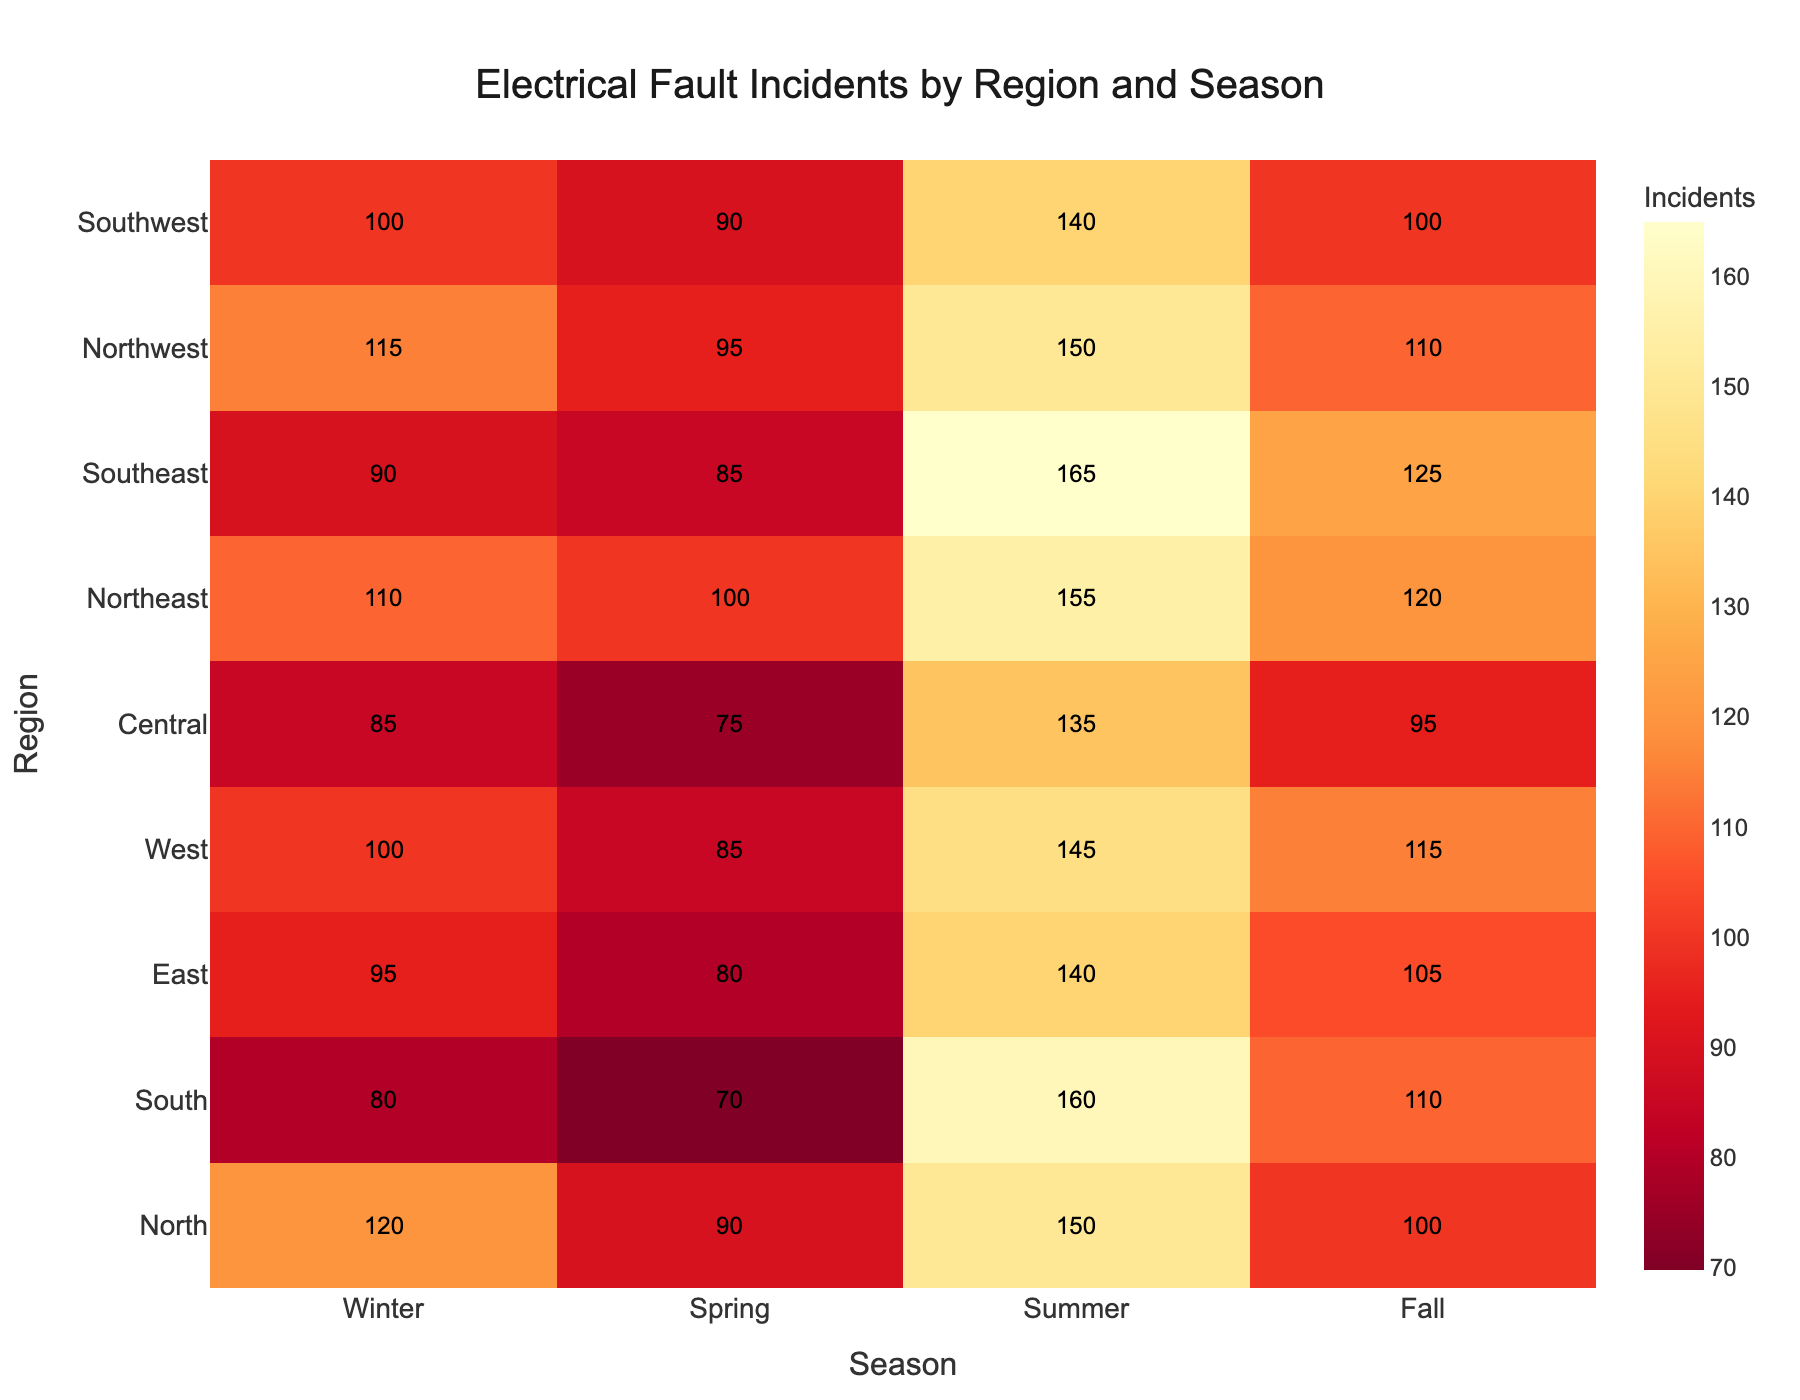What is the season with the most electrical fault incidents in the North region? To determine the season with the most electrical fault incidents in the North region, look at the values for the North region across all seasons. Winter has 120, Spring has 90, Summer has 150, and Fall has 100. The highest value is 150 in the Summer.
Answer: Summer Which region has the highest number of electrical fault incidents in the Winter? To find the region with the highest incidents in Winter, look at the values in the Winter column across all regions. The North region has 120, South has 80, East has 95, and so on. The highest value is 120 in the North region.
Answer: North What is the average number of electrical fault incidents in the Central region for all seasons? To find the average, sum all the incident values for the Central region and divide by the number of seasons. The values are 85 (Winter), 75 (Spring), 135 (Summer), and 95 (Fall). Sum them (85 + 75 + 135 + 95 = 390) and divide by 4 to get the average. The average is 390 / 4 = 97.5.
Answer: 97.5 Which season has the highest overall electrical fault incidents across all regions? To determine the season with the highest overall incidents, sum the incidents for each season across all regions and compare. For Winter: 120 + 80 + 95 + 100 + 85 + 110 + 90 + 115 + 100 = 895, for Spring: 90 + 70 + 80 + 85 + 75 + 100 + 85 + 95 + 90 = 770, for Summer: 150 + 160 + 140 + 145 + 135 + 155 + 165 + 150 + 140 = 1340, and for Fall: 100 + 110 + 105 + 115 + 95 + 120 + 125 + 110 + 100 = 980. Summer has the highest total of 1340.
Answer: Summer Which regions have more electrical fault incidents in Fall compared to Winter? To check which regions have more incidents in Fall compared to Winter, compare the values for Fall and Winter for each region. North: Winter (120) vs. Fall (100); South: Winter (80) vs. Fall (110); East: Winter (95) vs. Fall (105); West: Winter (100) vs. Fall (115); Central: Winter (85) vs. Fall (95); Northeast: Winter (110) vs. Fall (120); Southeast: Winter (90) vs. Fall (125); Northwest: Winter (115) vs. Fall (110); Southwest: Winter (100) vs. Fall (100). The regions are South, East, West, Central, Northeast, and Southeast.
Answer: South, East, West, Central, Northeast, Southeast 